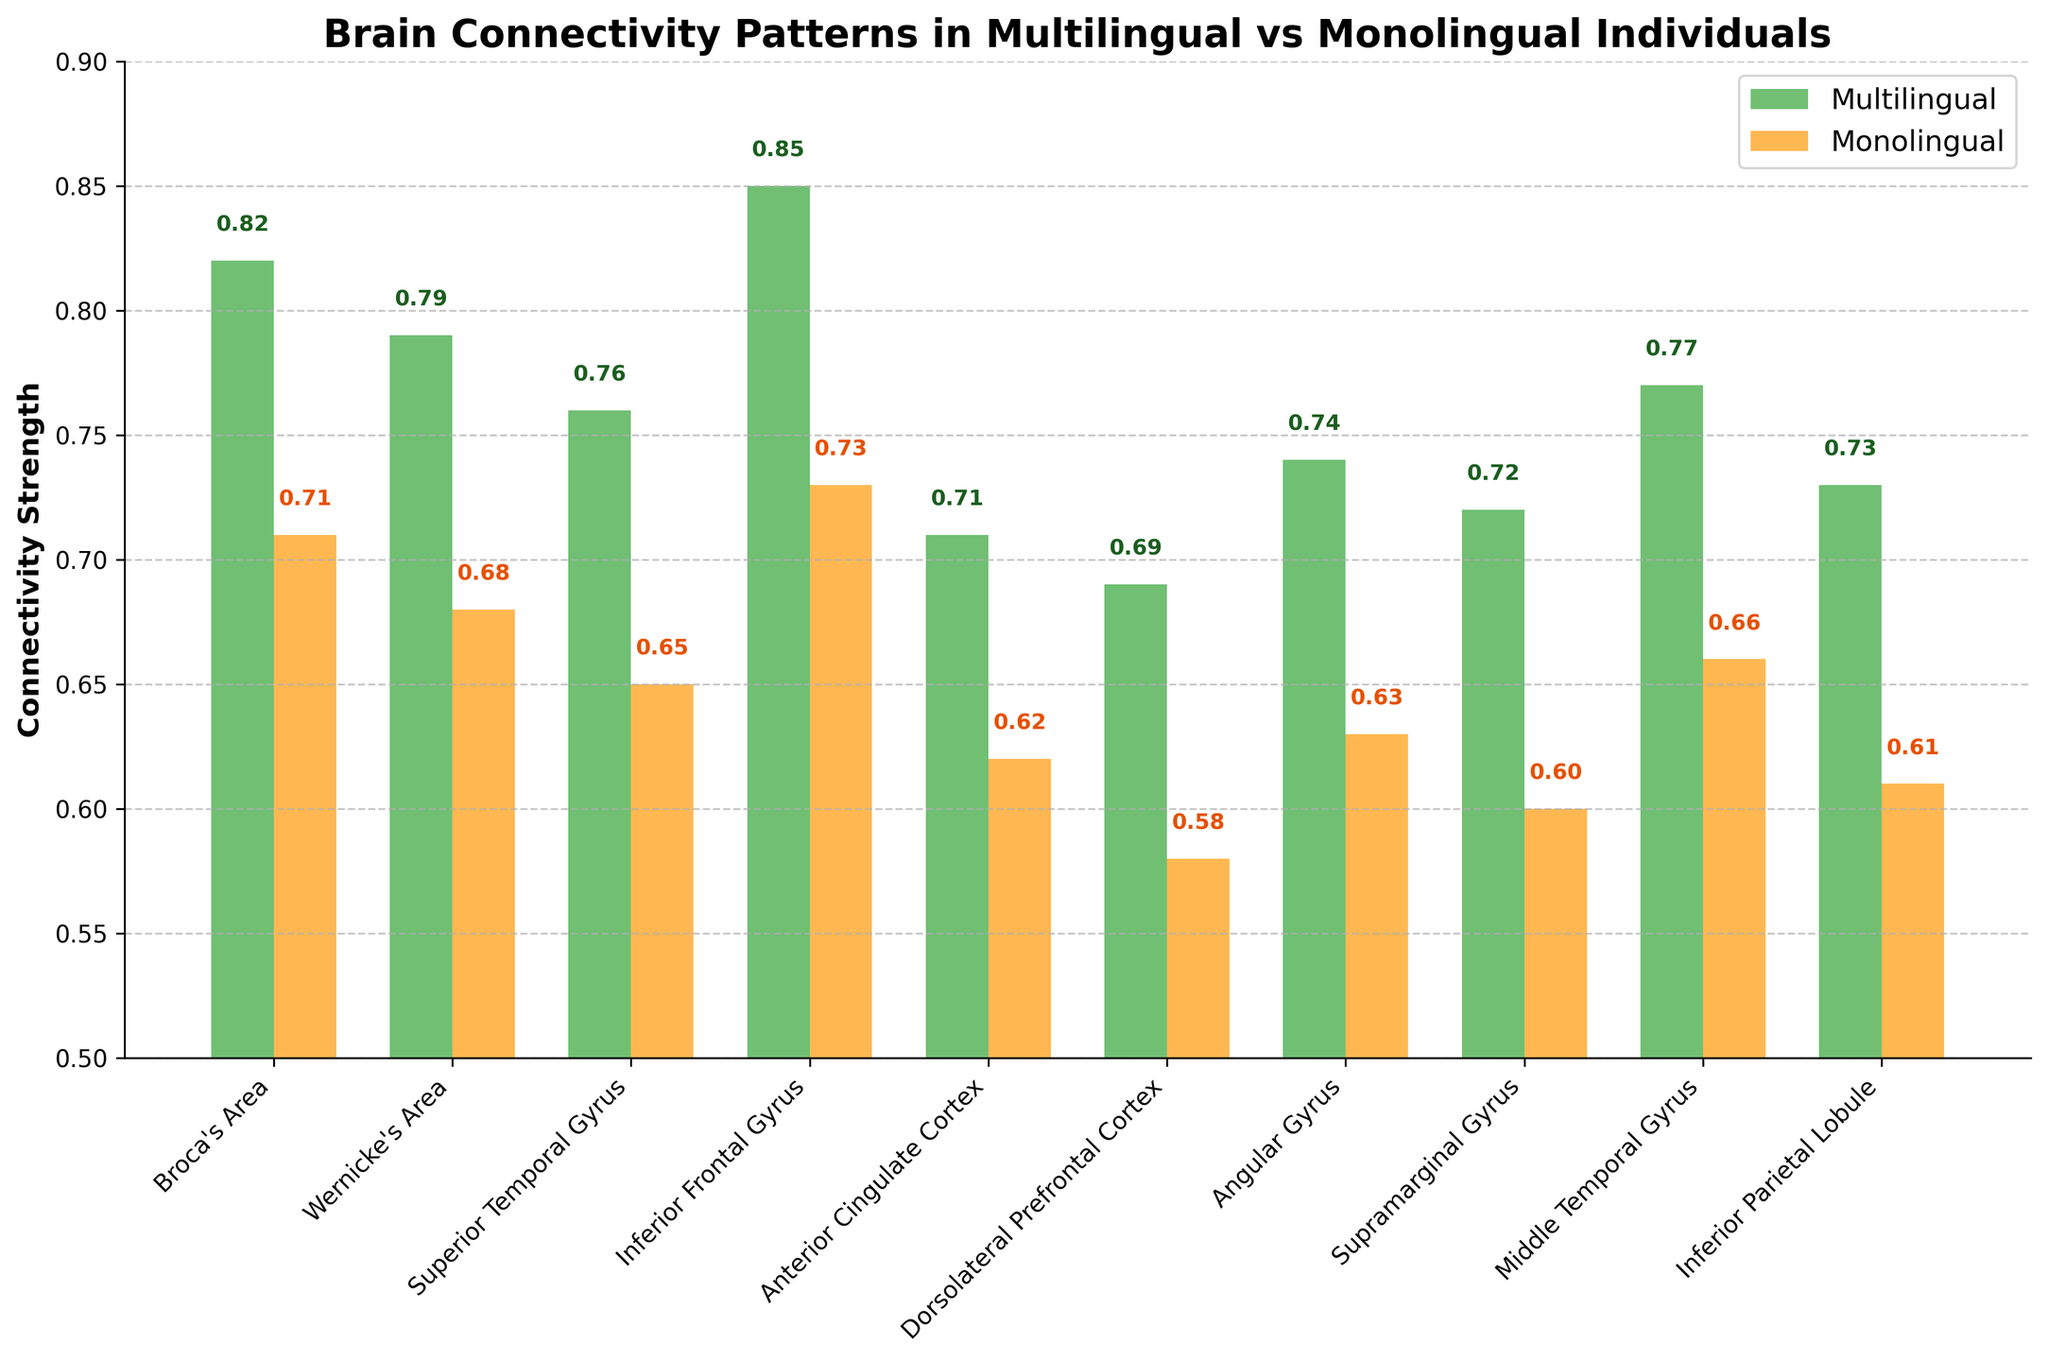What is the brain region with the highest connectivity in multilingual individuals? To find the region with the highest connectivity, look at the height of the green bars representing multilingual connectivity. The Inferior Frontal Gyrus has the highest value at 0.85.
Answer: Inferior Frontal Gyrus Which brain region shows the smallest difference in connectivity between multilingual and monolingual individuals? Calculate the difference in connectivity for each brain region by subtracting the monolingual value from the multilingual value. The Anterior Cingulate Cortex has the smallest difference (0.71 - 0.62 = 0.09).
Answer: Anterior Cingulate Cortex By how much does the multilingual connectivity in Broca's Area exceed that in the Monolingual group? Subtract the monolingual connectivity value from the multilingual value for Broca's Area (0.82 - 0.71 = 0.11).
Answer: 0.11 What is the average connectivity for multilingual individuals across all brain regions? Sum all multilingual connectivity values and divide by the number of brain regions (0.82 + 0.79 + 0.76 + 0.85 + 0.71 + 0.69 + 0.74 + 0.72 + 0.77 + 0.73) / 10 = 7.58 / 10 = 0.758.
Answer: 0.758 Which connectivity value is higher for the Superior Temporal Gyrus, multilingual or monolingual, and by how much? Compare the connectivity values for the Superior Temporal Gyrus: multilingual (0.76) and monolingual (0.65). The difference is 0.76 - 0.65 = 0.11.
Answer: Multilingual, 0.11 In which brain region do multilingual individuals and monolingual individuals have almost equal connectivity? Identify regions where the difference in connectivity is minimal. The Anterior Cingulate Cortex has the smallest difference (0.71 - 0.62 = 0.09), but it's not very close to equal. Thus, none of the brain regions have almost equal connectivity.
Answer: None What is the sum of monolingual connectivity values in the Broca's Area and the Inferior Frontal Gyrus? Add the monolingual connectivity values for Broca's Area (0.71) and the Inferior Frontal Gyrus (0.73): 0.71 + 0.73 = 1.44.
Answer: 1.44 Rank the first three brain regions from highest to lowest in multilingual connectivity. Look at multilingual connectivity values and rank the top three: Inferior Frontal Gyrus (0.85), Broca's Area (0.82), and Wernicke's Area (0.79).
Answer: Inferior Frontal Gyrus, Broca's Area, Wernicke's Area 